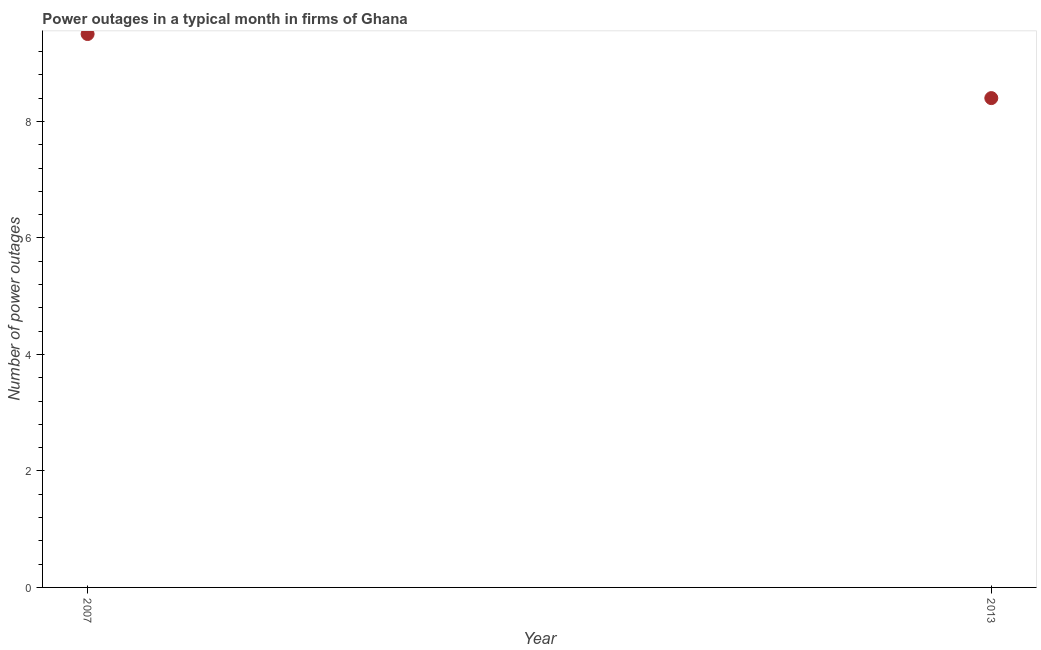What is the number of power outages in 2007?
Offer a terse response. 9.5. In which year was the number of power outages minimum?
Provide a succinct answer. 2013. What is the sum of the number of power outages?
Your response must be concise. 17.9. What is the difference between the number of power outages in 2007 and 2013?
Keep it short and to the point. 1.1. What is the average number of power outages per year?
Your answer should be compact. 8.95. What is the median number of power outages?
Provide a short and direct response. 8.95. Do a majority of the years between 2013 and 2007 (inclusive) have number of power outages greater than 4 ?
Your answer should be compact. No. What is the ratio of the number of power outages in 2007 to that in 2013?
Your answer should be very brief. 1.13. In how many years, is the number of power outages greater than the average number of power outages taken over all years?
Your answer should be very brief. 1. How many years are there in the graph?
Your answer should be very brief. 2. What is the title of the graph?
Make the answer very short. Power outages in a typical month in firms of Ghana. What is the label or title of the X-axis?
Give a very brief answer. Year. What is the label or title of the Y-axis?
Your answer should be compact. Number of power outages. What is the Number of power outages in 2007?
Offer a very short reply. 9.5. What is the ratio of the Number of power outages in 2007 to that in 2013?
Offer a very short reply. 1.13. 